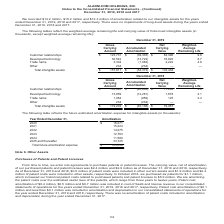According to Alarmcom Holdings's financial document, What was the amortization related to the company's intangible assets in 2019? According to the financial document, $14.2 million (in millions). The relevant text states: "We recorded $14.2 million, $15.2 million and $12.3 million of amortization related to our intangible assets for the years end..." Also, What was the trade name gross carrying amount in 2019? According to the financial document, 3,304 (in thousands). The relevant text states: "technology 30,542 (13,722) 16,820 8.7 Trade name 3,304 (1,082) 2,222 4.8 Other 234 (234) — — Total intangible assets $ 157,811 $ (54,373) $ 103,438..." Also, What was the accumulated amortization for Other in 2019? According to the financial document, 234 (in thousands). The relevant text states: ",820 8.7 Trade name 3,304 (1,082) 2,222 4.8 Other 234 (234) — — Total intangible assets $ 157,811 $ (54,373) $ 103,438..." Also, How many intangible assets in 2019 had a net carrying value of more than $50,000 thousand? Based on the analysis, there are 1 instances. The counting process: Customer relationships. Also, can you calculate: What is the percentage constitution of the gross carrying amount of customer relationships among the total gross carrying amount of the total intangible assets? Based on the calculation: 123,731/157,811, the result is 78.4 (percentage). This is based on the information: "4.8 Other 234 (234) — — Total intangible assets $ 157,811 $ (54,373) $ 103,438 - Average Remaining Life Customer relationships $ 123,731 $ (39,335) $ 84,396 9.8 Developed technology 30,542 (13,722) 16..." The key data points involved are: 123,731, 157,811. Also, can you calculate: What is the difference in the net carrying value between customer relationships and developed technology? Based on the calculation: 84,396-16,820, the result is 67576 (in thousands). This is based on the information: "$ 84,396 9.8 Developed technology 30,542 (13,722) 16,820 8.7 Trade name 3,304 (1,082) 2,222 4.8 Other 234 (234) — — Total intangible assets $ 157,811 $ (54, ife Customer relationships $ 123,731 $ (39,..." The key data points involved are: 16,820, 84,396. 